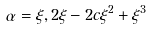<formula> <loc_0><loc_0><loc_500><loc_500>\alpha = \xi , 2 \xi - 2 c \xi ^ { 2 } + \xi ^ { 3 }</formula> 